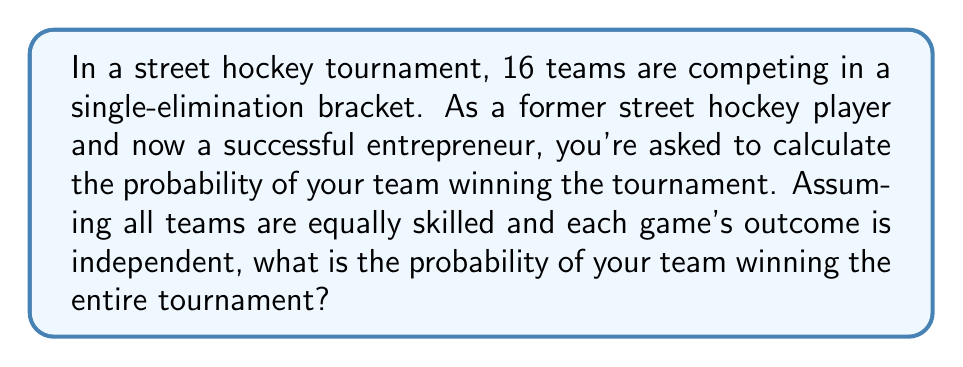Could you help me with this problem? Let's approach this step-by-step:

1) In a single-elimination tournament with 16 teams, a team needs to win 4 games to become the champion (Round of 16, Quarter-finals, Semi-finals, and Finals).

2) For each game, assuming equal skill levels, the probability of winning is 1/2.

3) To win the tournament, a team must win all 4 games. Since the games are independent, we can use the multiplication rule of probability.

4) The probability of winning the tournament is:

   $$P(\text{winning tournament}) = P(\text{winning game 1}) \times P(\text{winning game 2}) \times P(\text{winning game 3}) \times P(\text{winning game 4})$$

5) Substituting the probabilities:

   $$P(\text{winning tournament}) = \frac{1}{2} \times \frac{1}{2} \times \frac{1}{2} \times \frac{1}{2} = \left(\frac{1}{2}\right)^4$$

6) Calculate the final probability:

   $$P(\text{winning tournament}) = \frac{1}{16} = 0.0625$$

This can also be interpreted as a 6.25% chance of winning the tournament.

As an entrepreneur, you might recognize this as similar to the probability of success in a series of business ventures, where each step must be successful for the overall project to succeed.
Answer: The probability of winning the tournament is $\frac{1}{16}$ or 0.0625 (6.25%). 